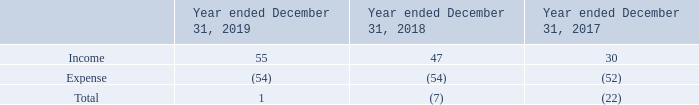Interest income (expense), net consisted of the following:
Interest income is related to the cash and cash equivalents held by the Company. Interest expense recorded in 2019, 2018 and 2017 included respectively a charge of $39 million, $38 million and $37 million on the senior unsecured convertible bonds issued in July 2017 and July 2014, of which respectively $37 million, $36 million and $33 million was a non-cash interest expense resulting from the accretion of the discount on the liability component. Net interest includes also charges related to the banking fees and the sale of trade and other receivables.
No borrowing cost was capitalized in 2019, 2018 and 2017. Interest income on government bonds and floating rate notes classified as available-for-sale marketable securities amounted to $6 million for the year ended December 31, 2019, $6 million for the year ended December 31, 2018 and $6 million for the year ended December 31, 2017.
What was the interest expense in 2018? $38 million. What was the interest income in 2019? $6 million. What charges are included in Net interest? The banking fees and the sale of trade and other receivables. What is the average Income?
Answer scale should be: million. (55+47+30) / 3
Answer: 44. What is the average Expense?
Answer scale should be: million. (54+54+52) / 3
Answer: 53.33. What is the increase/ (decrease) in income from December 31, 2018 to 2019?
Answer scale should be: million. 55-47
Answer: 8. 